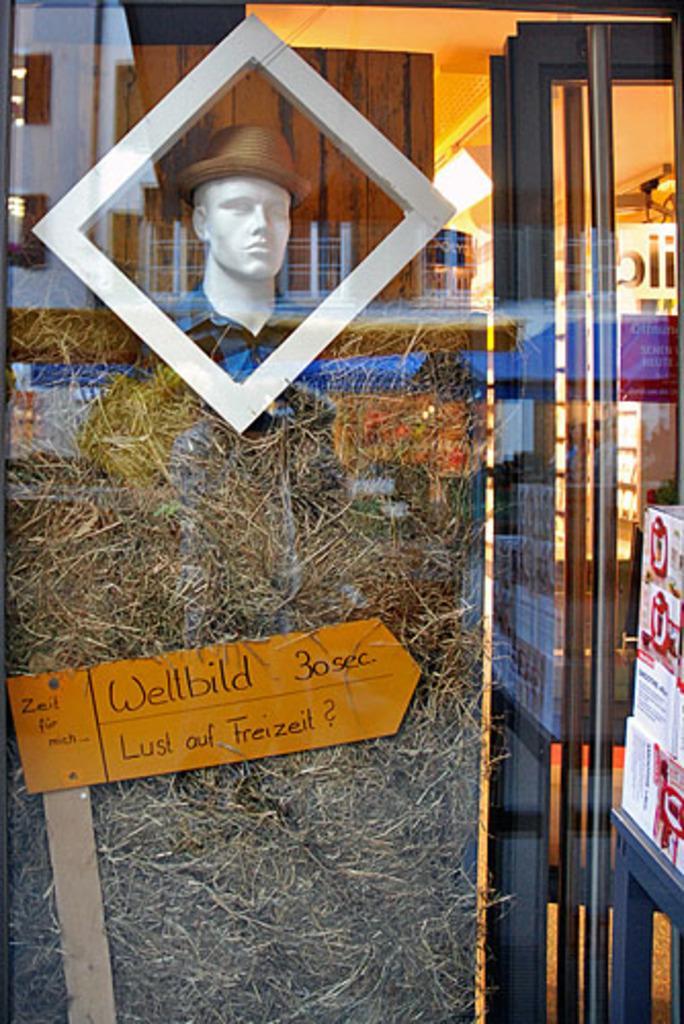Please provide a concise description of this image. In this image in the foreground there is one glass window and through the window we can see a manikin, that, grass, board, lights, boxes, wooden wall and some other objects. 